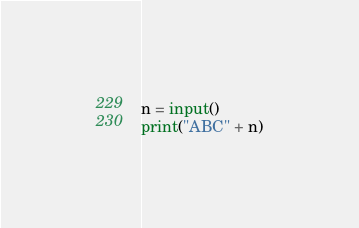Convert code to text. <code><loc_0><loc_0><loc_500><loc_500><_Python_>n = input()
print("ABC" + n)</code> 